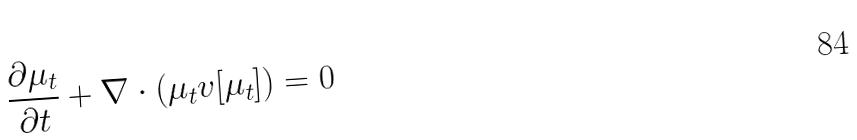<formula> <loc_0><loc_0><loc_500><loc_500>\frac { \partial \mu _ { t } } { \partial t } + \nabla \cdot ( \mu _ { t } v [ \mu _ { t } ] ) = 0</formula> 